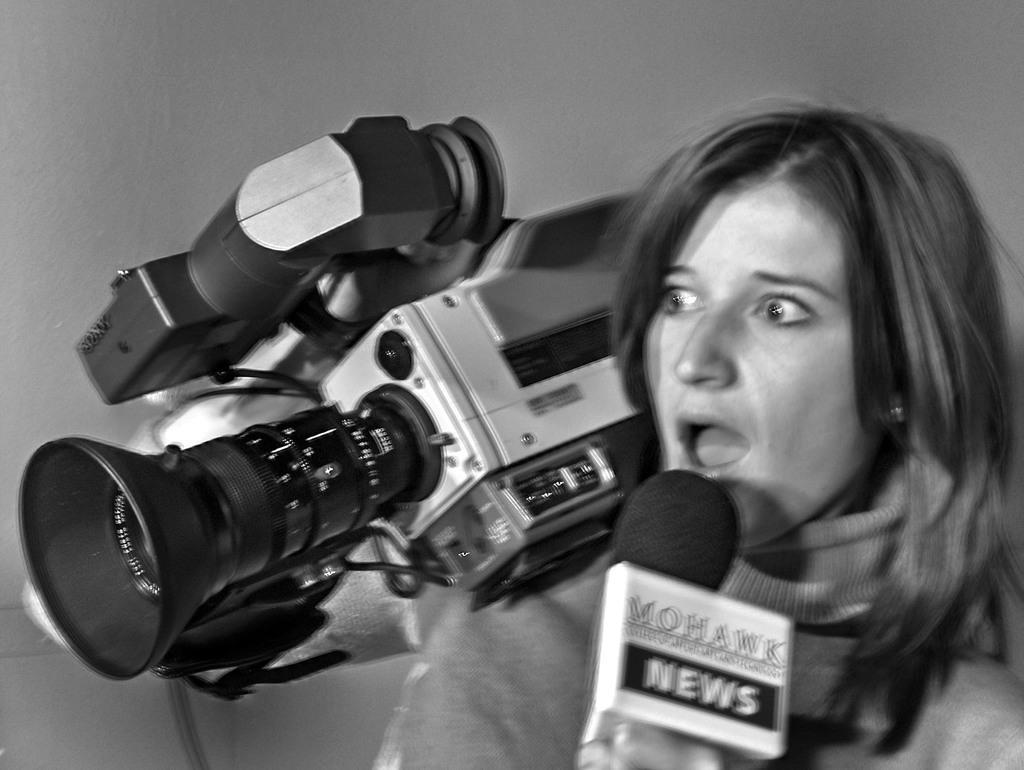Could you give a brief overview of what you see in this image? In this image, woman is holding microphone and camera on his hands and she open her mouth. 